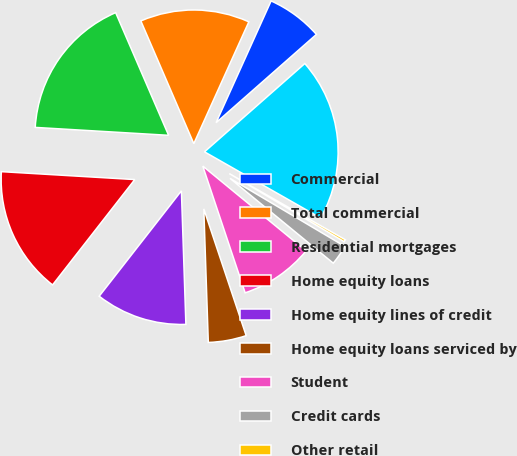Convert chart. <chart><loc_0><loc_0><loc_500><loc_500><pie_chart><fcel>Commercial<fcel>Total commercial<fcel>Residential mortgages<fcel>Home equity loans<fcel>Home equity lines of credit<fcel>Home equity loans serviced by<fcel>Student<fcel>Credit cards<fcel>Other retail<fcel>Total retail<nl><fcel>6.76%<fcel>13.24%<fcel>17.57%<fcel>15.4%<fcel>11.08%<fcel>4.6%<fcel>8.92%<fcel>2.43%<fcel>0.27%<fcel>19.73%<nl></chart> 